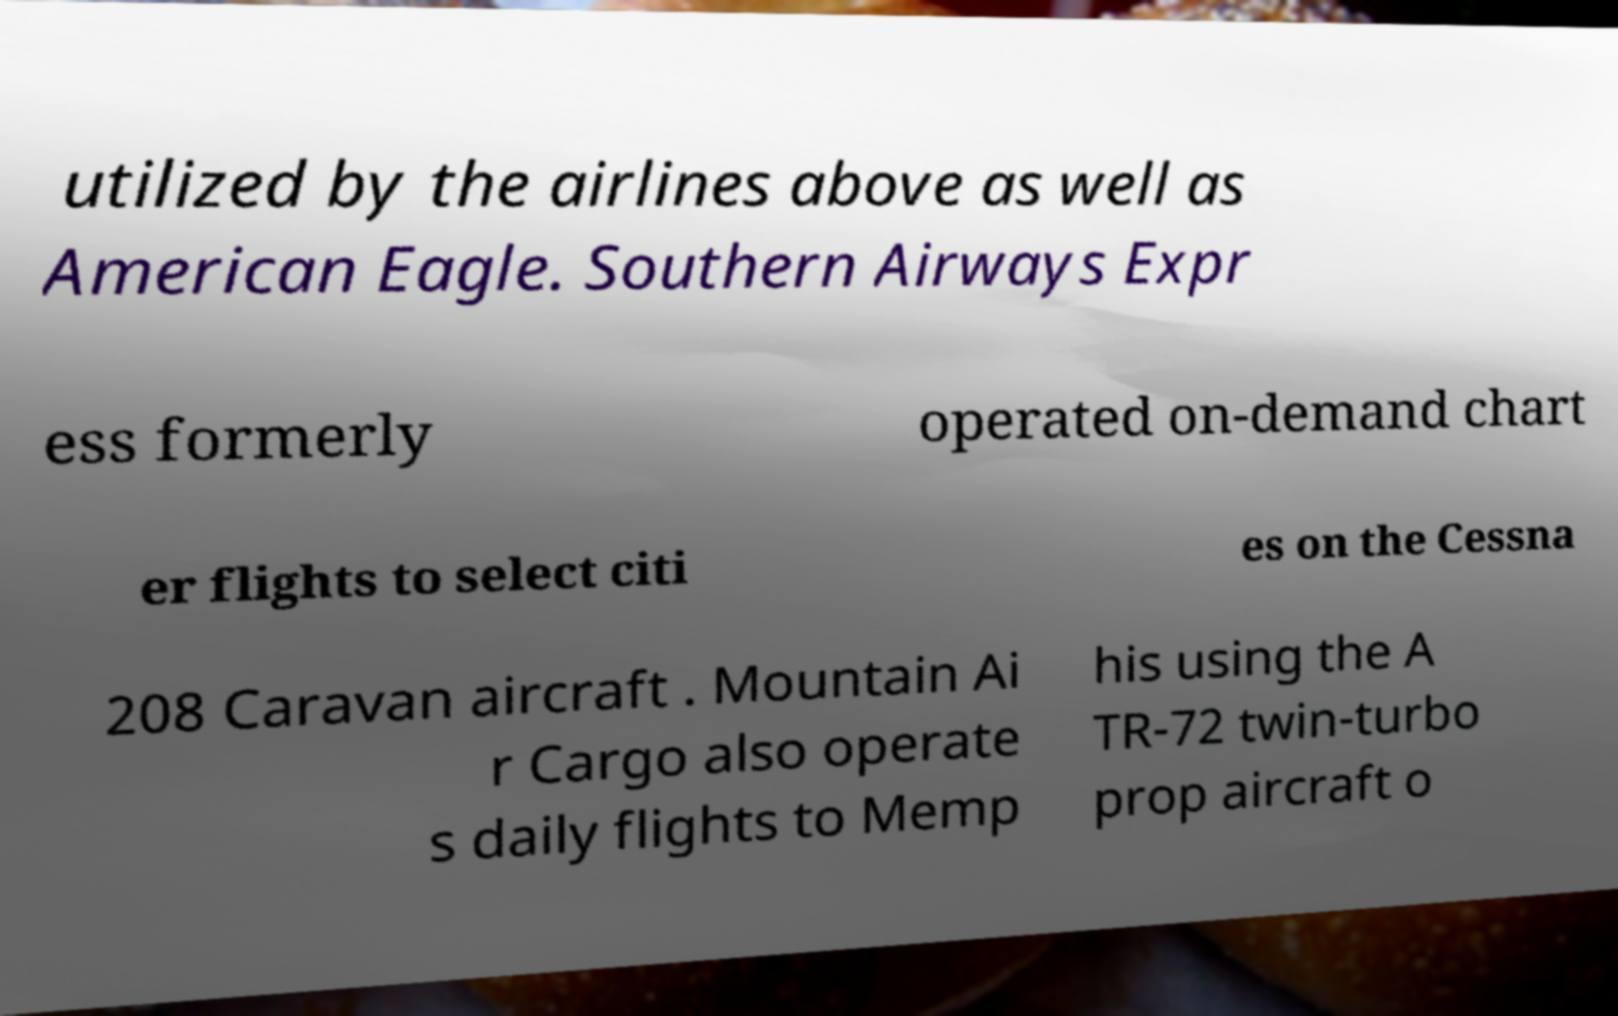Can you accurately transcribe the text from the provided image for me? utilized by the airlines above as well as American Eagle. Southern Airways Expr ess formerly operated on-demand chart er flights to select citi es on the Cessna 208 Caravan aircraft . Mountain Ai r Cargo also operate s daily flights to Memp his using the A TR-72 twin-turbo prop aircraft o 